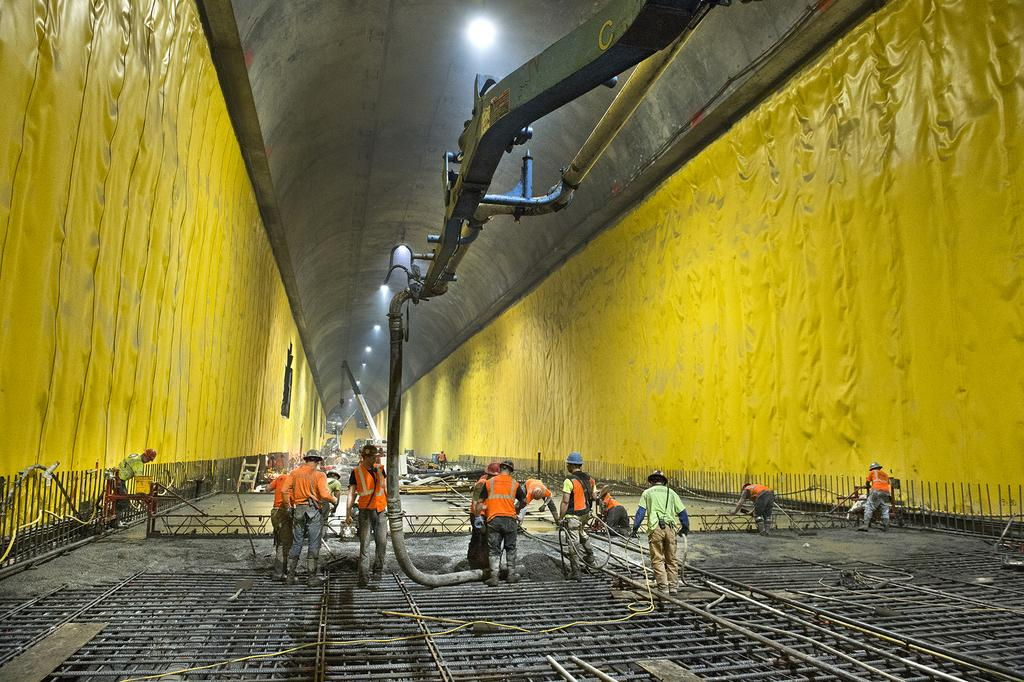Who or what is present in the image? There are people in the image. What color can be seen on both sides of the wall in the image? There is yellow color on both the left and right sides of the wall in the image. What is visible at the top of the image? There are lights visible at the top of the image. Can you hear the brother whistling in the image? There is no mention of a brother or whistling in the image, so it cannot be heard. 